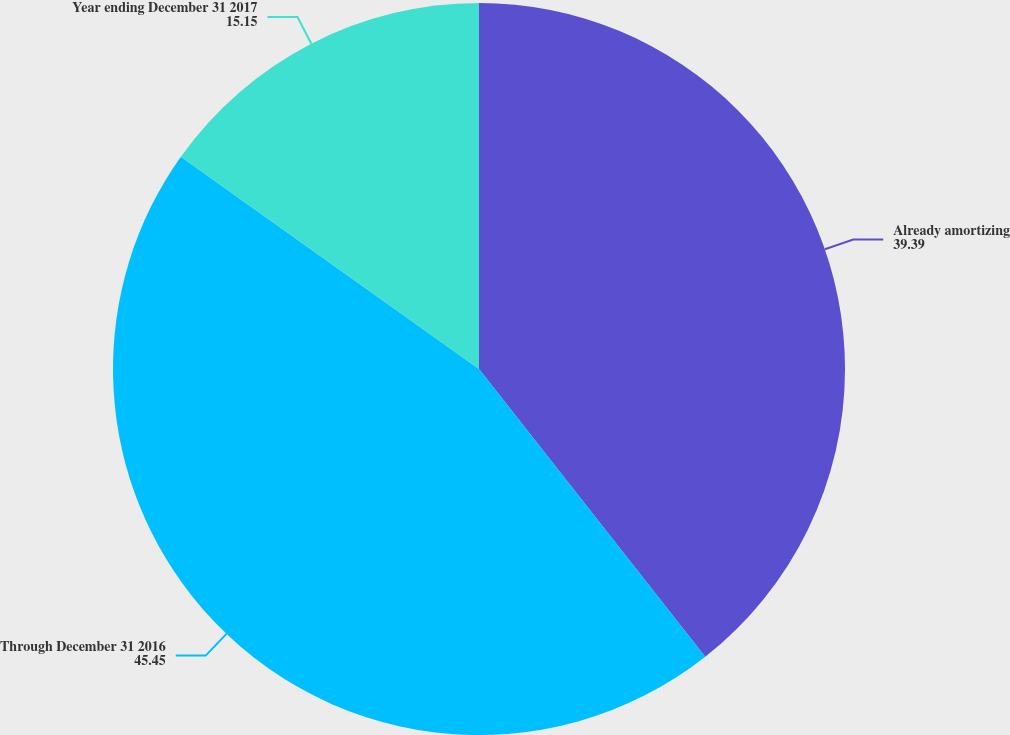<chart> <loc_0><loc_0><loc_500><loc_500><pie_chart><fcel>Already amortizing<fcel>Through December 31 2016<fcel>Year ending December 31 2017<nl><fcel>39.39%<fcel>45.45%<fcel>15.15%<nl></chart> 